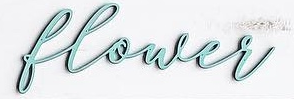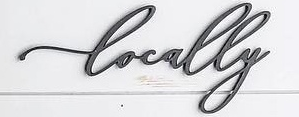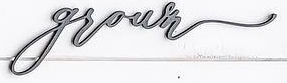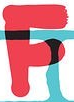Read the text content from these images in order, separated by a semicolon. blower; Locally; grown; F 